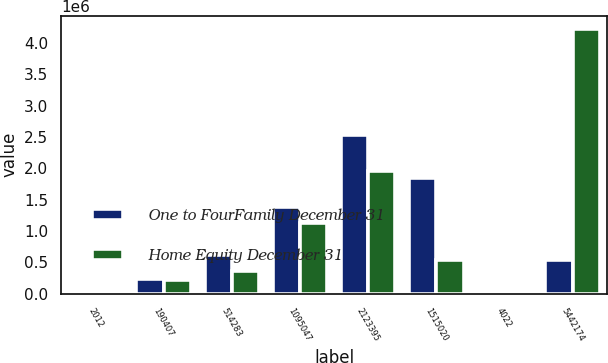Convert chart to OTSL. <chart><loc_0><loc_0><loc_500><loc_500><stacked_bar_chart><ecel><fcel>2012<fcel>190407<fcel>514283<fcel>1095047<fcel>2123395<fcel>1515020<fcel>4022<fcel>5442174<nl><fcel>One to FourFamily December 31<fcel>2011<fcel>239868<fcel>620464<fcel>1.37775e+06<fcel>2.52856e+06<fcel>1.8411e+06<fcel>8073<fcel>542203<nl><fcel>Home Equity December 31<fcel>2012<fcel>218182<fcel>359737<fcel>1.13134e+06<fcel>1.96295e+06<fcel>542203<fcel>9052<fcel>4.22346e+06<nl></chart> 